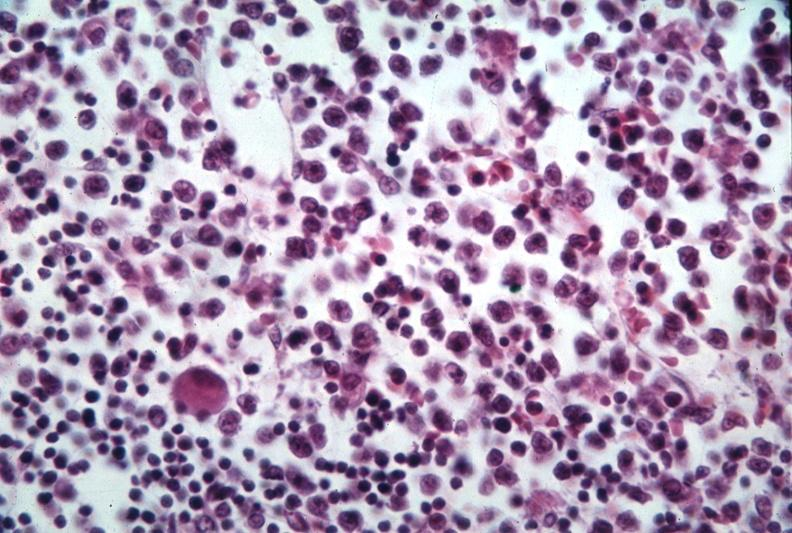what is present?
Answer the question using a single word or phrase. Bone marrow 